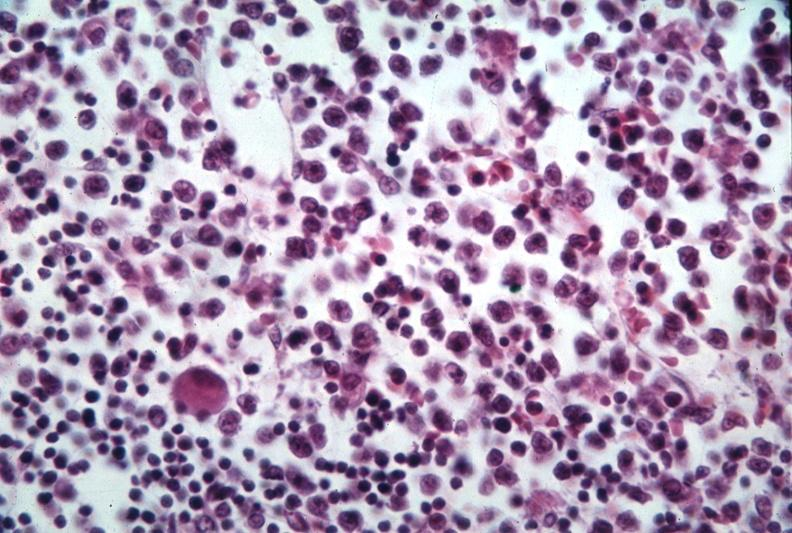what is present?
Answer the question using a single word or phrase. Bone marrow 